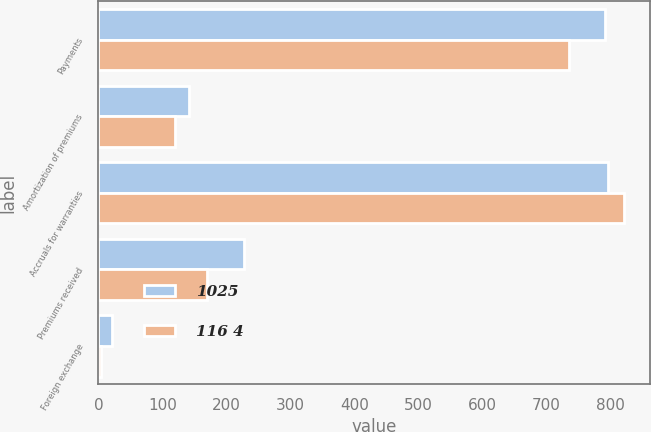Convert chart. <chart><loc_0><loc_0><loc_500><loc_500><stacked_bar_chart><ecel><fcel>Payments<fcel>Amortization of premiums<fcel>Accruals for warranties<fcel>Premiums received<fcel>Foreign exchange<nl><fcel>1025<fcel>792<fcel>142<fcel>797<fcel>228<fcel>21<nl><fcel>116 4<fcel>736<fcel>120<fcel>821<fcel>170<fcel>4<nl></chart> 